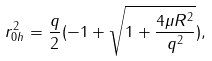Convert formula to latex. <formula><loc_0><loc_0><loc_500><loc_500>r _ { 0 h } ^ { 2 } = \frac { q } { 2 } ( - 1 + \sqrt { 1 + \frac { 4 \mu R ^ { 2 } } { q ^ { 2 } } } ) ,</formula> 